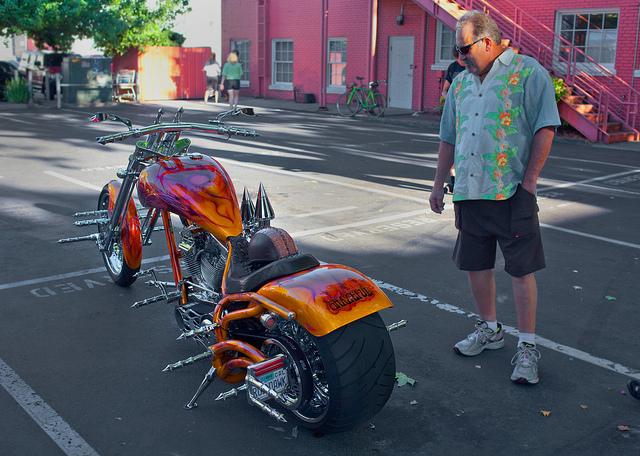Is this a customized bike?
Write a very short answer. Yes. Is this motorcycle painted in bright colors?
Quick response, please. Yes. Is the man impressed with the motorcycle?
Answer briefly. Yes. 